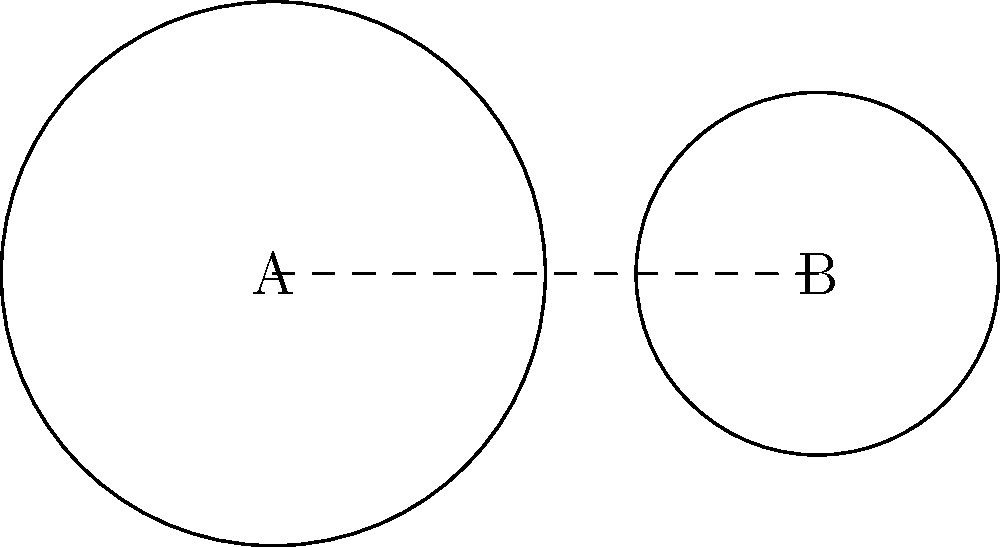Two Chicago Bears logos are represented by circles A and B. Logo A has a radius 1.5 times larger than logo B. If the distance between the centers of the logos is 3 units, what is the ratio of the area of logo A to the area of logo B? Let's approach this step-by-step:

1) Let's denote the radius of logo B as $r$. Then, the radius of logo A is $1.5r$.

2) The area of a circle is given by the formula $A = \pi r^2$.

3) Area of logo A: $A_A = \pi (1.5r)^2 = 2.25\pi r^2$

4) Area of logo B: $A_B = \pi r^2$

5) The ratio of the areas is:

   $$\frac{A_A}{A_B} = \frac{2.25\pi r^2}{\pi r^2} = 2.25$$

6) This can be simplified to $\frac{9}{4}$ or $2.25:1$.

Therefore, the area of logo A is 2.25 times the area of logo B.
Answer: $\frac{9}{4}$ or $2.25:1$ 